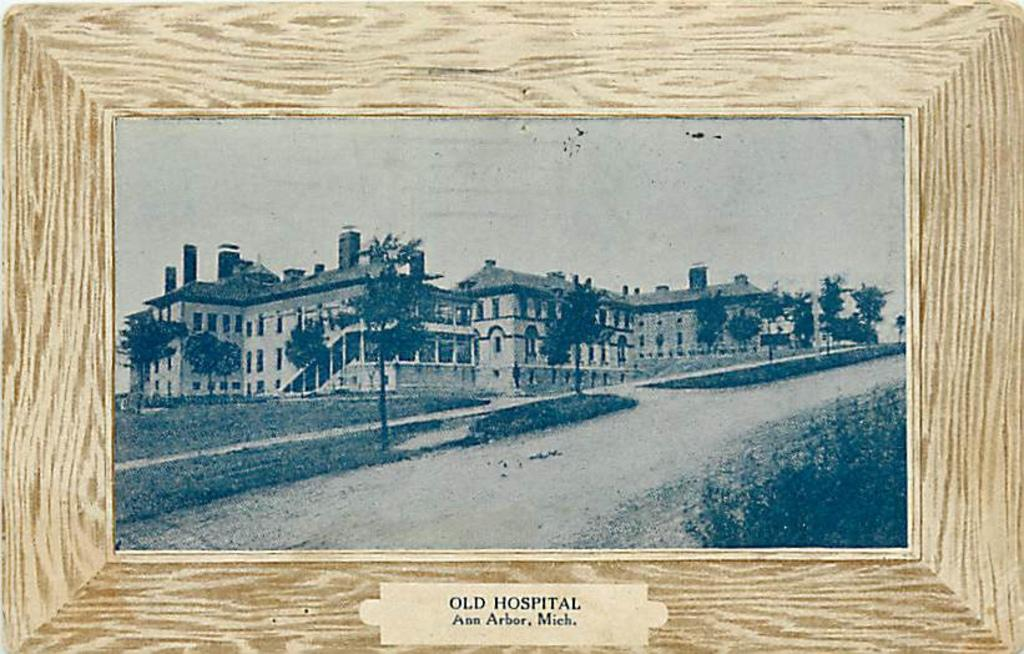<image>
Give a short and clear explanation of the subsequent image. A black and white picture in a frame of Old Hospital in Ann Arbor, Mich. 